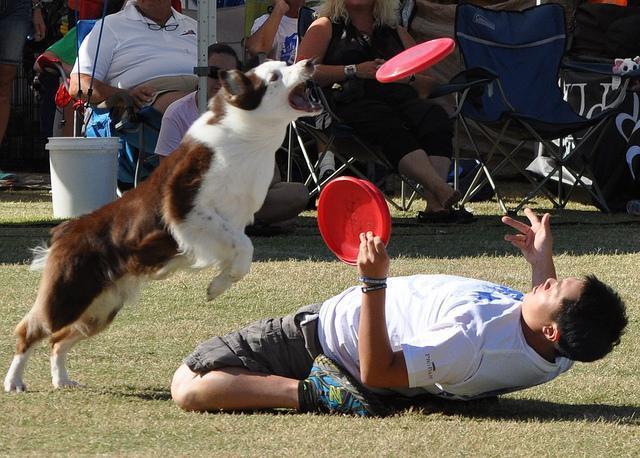How many frisbees are there?
Give a very brief answer. 2. How many chairs are in the picture?
Give a very brief answer. 4. How many people are there?
Give a very brief answer. 6. How many clocks are on the tower?
Give a very brief answer. 0. 